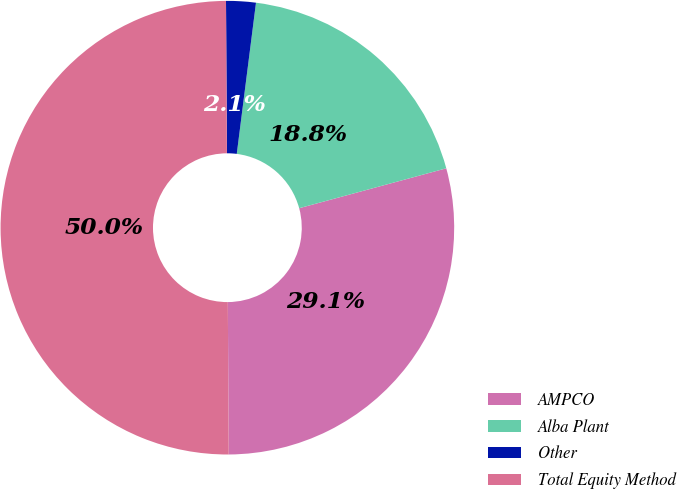Convert chart. <chart><loc_0><loc_0><loc_500><loc_500><pie_chart><fcel>AMPCO<fcel>Alba Plant<fcel>Other<fcel>Total Equity Method<nl><fcel>29.12%<fcel>18.77%<fcel>2.11%<fcel>50.0%<nl></chart> 